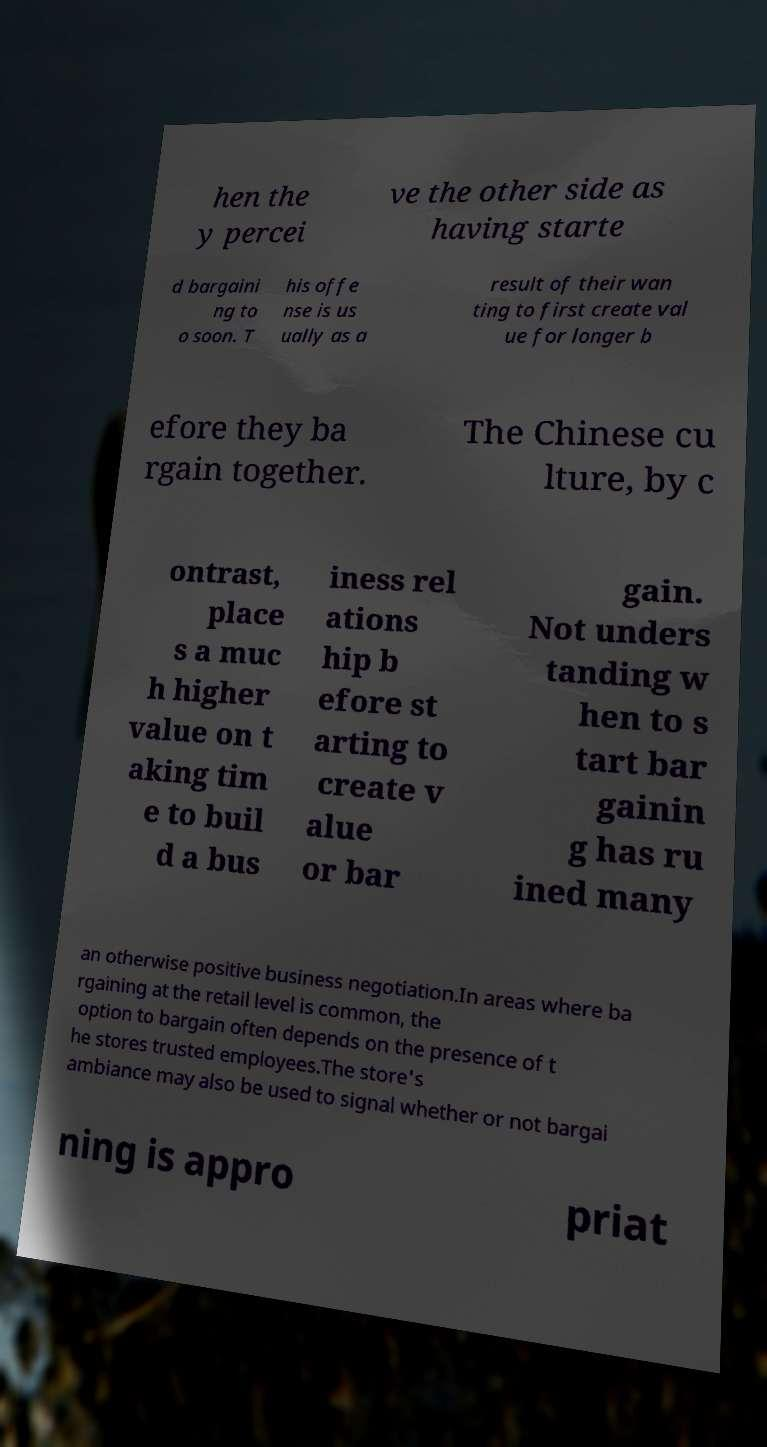Can you accurately transcribe the text from the provided image for me? hen the y percei ve the other side as having starte d bargaini ng to o soon. T his offe nse is us ually as a result of their wan ting to first create val ue for longer b efore they ba rgain together. The Chinese cu lture, by c ontrast, place s a muc h higher value on t aking tim e to buil d a bus iness rel ations hip b efore st arting to create v alue or bar gain. Not unders tanding w hen to s tart bar gainin g has ru ined many an otherwise positive business negotiation.In areas where ba rgaining at the retail level is common, the option to bargain often depends on the presence of t he stores trusted employees.The store's ambiance may also be used to signal whether or not bargai ning is appro priat 